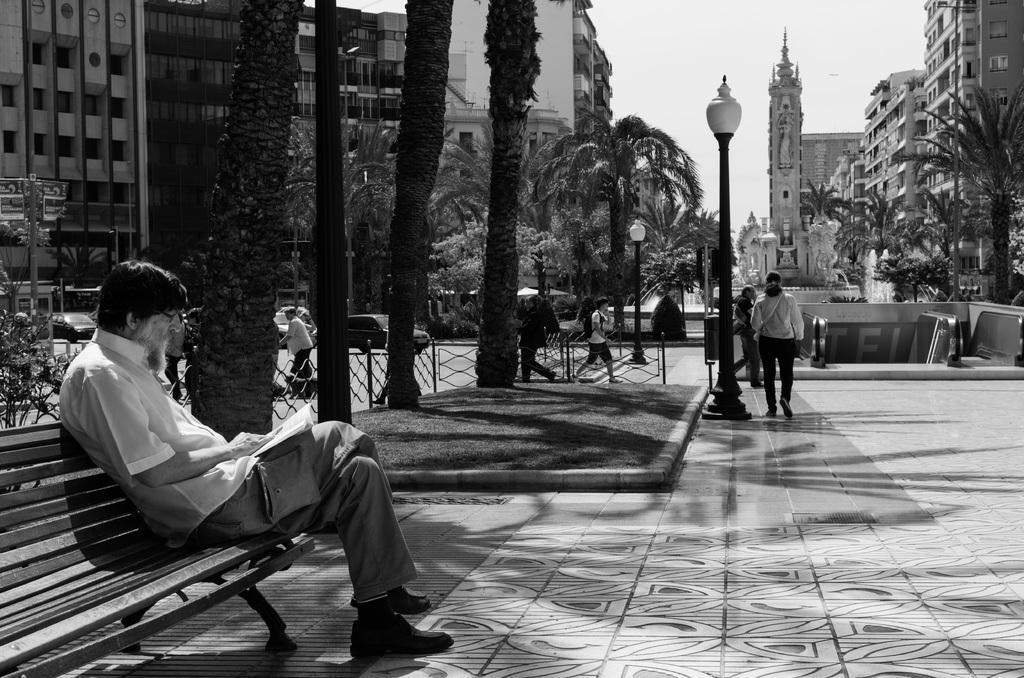Can you describe this image briefly? In the image on the left we can see one man sitting on the bench. In the center we can see few persons were walking on the road. And coming to background we can see trees,sky,street light etc. 